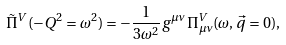<formula> <loc_0><loc_0><loc_500><loc_500>\tilde { \Pi } ^ { V } ( - Q ^ { 2 } = \omega ^ { 2 } ) = - \frac { 1 } { 3 \omega ^ { 2 } } g ^ { \mu \nu } \Pi _ { \mu \nu } ^ { V } ( \omega , \vec { q } = 0 ) ,</formula> 